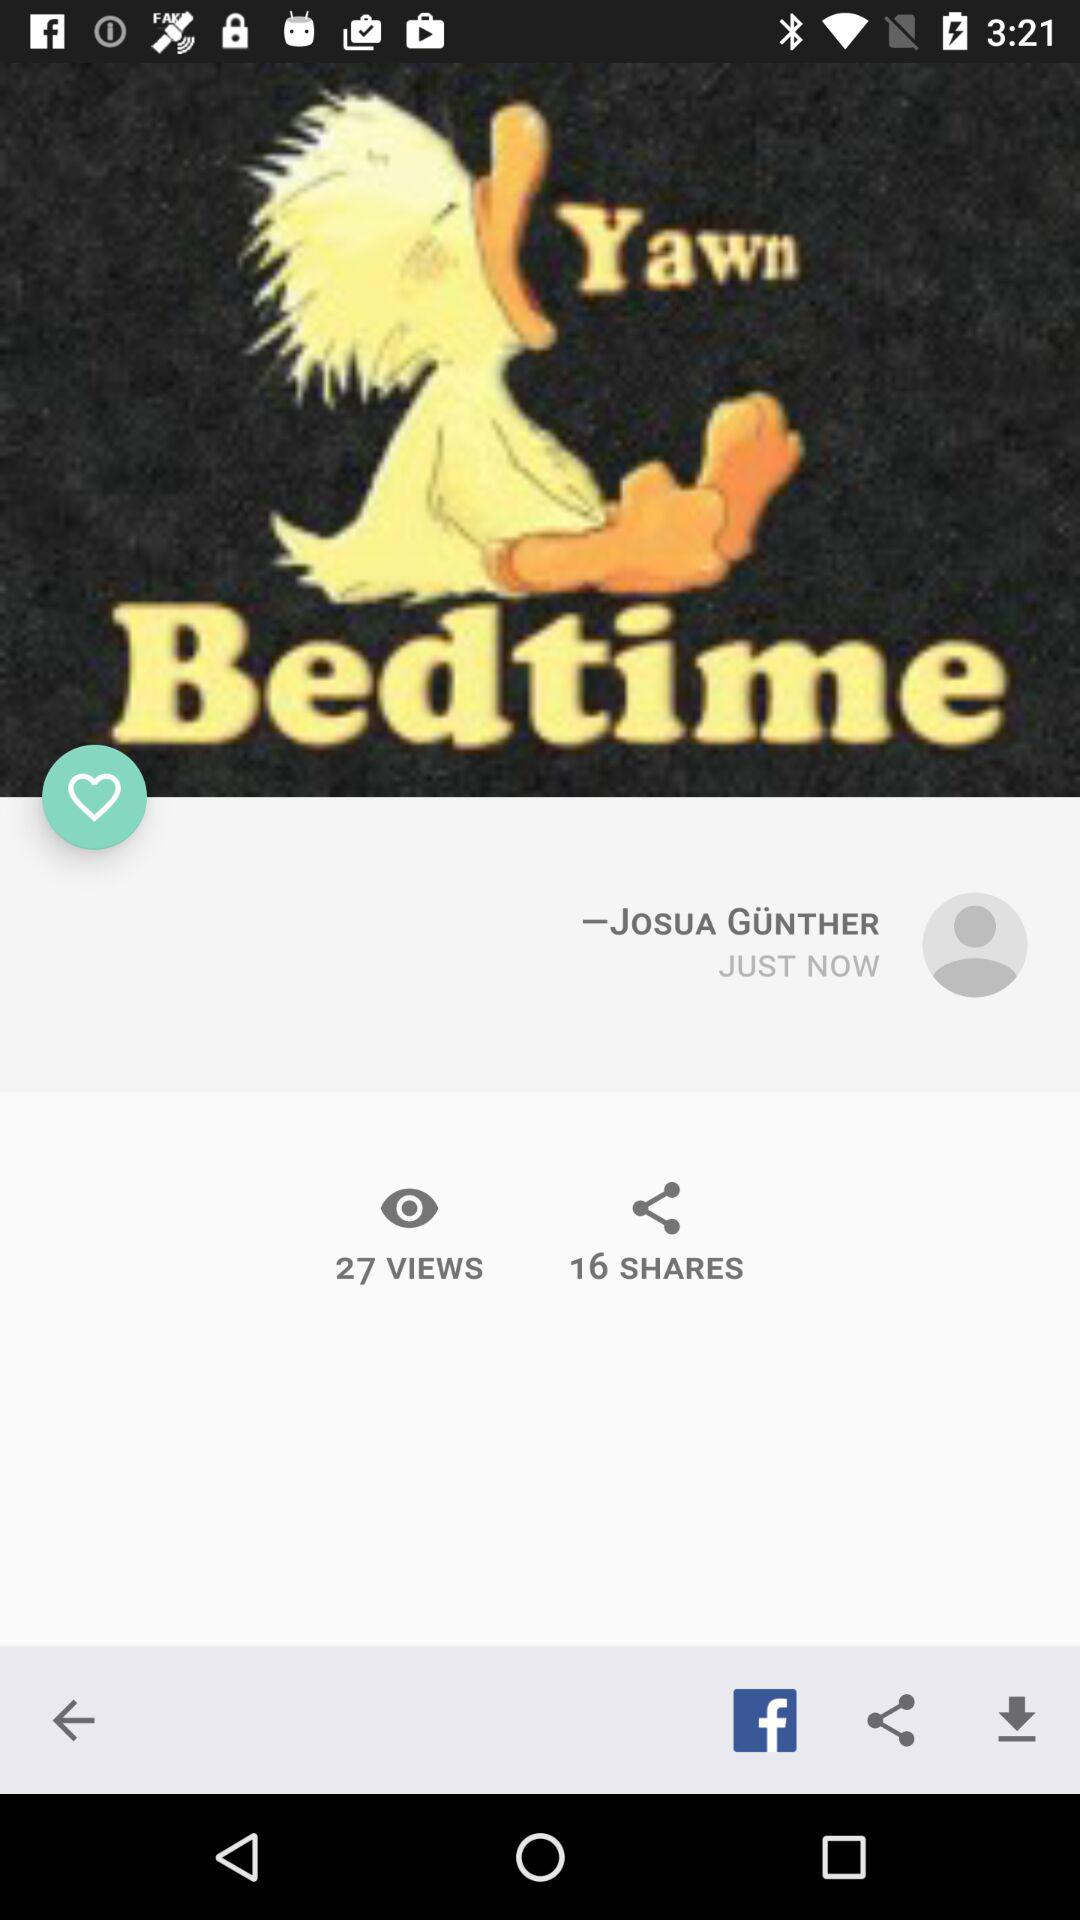How many more views are there than shares?
Answer the question using a single word or phrase. 11 